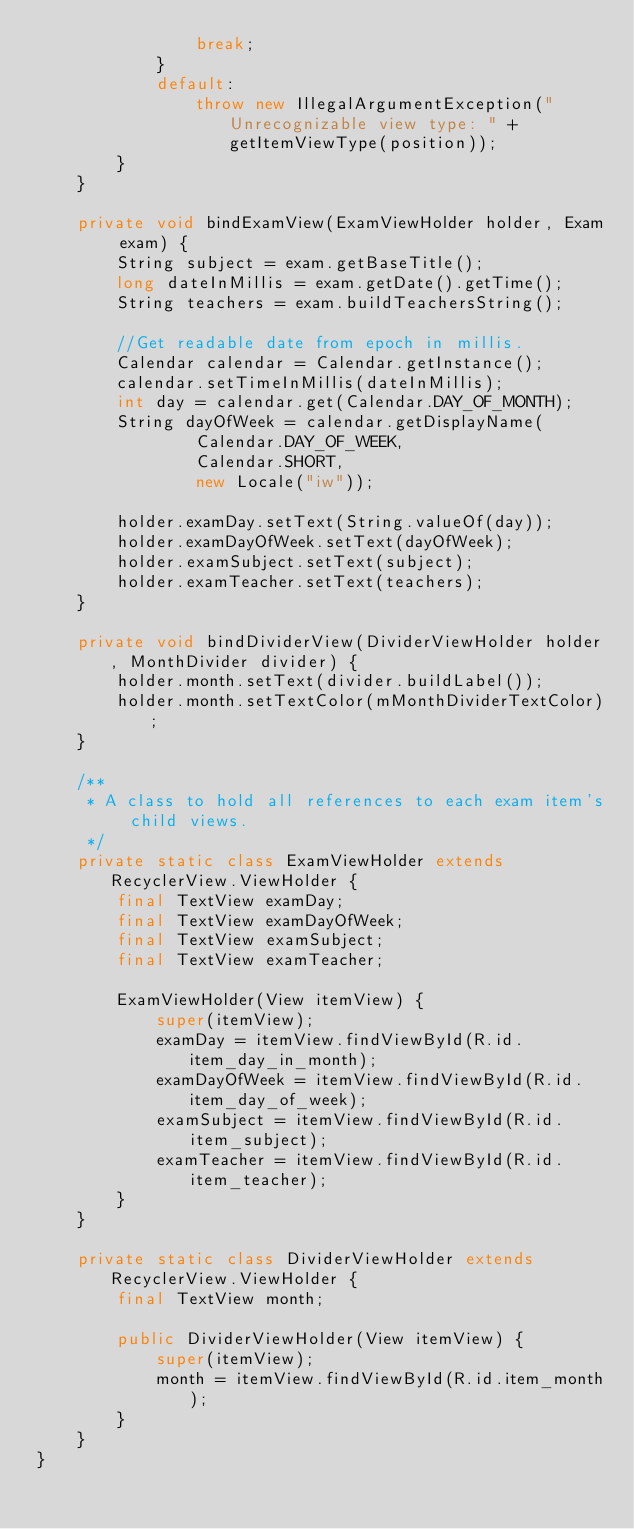<code> <loc_0><loc_0><loc_500><loc_500><_Java_>                break;
            }
            default:
                throw new IllegalArgumentException("Unrecognizable view type: " + getItemViewType(position));
        }
    }

    private void bindExamView(ExamViewHolder holder, Exam exam) {
        String subject = exam.getBaseTitle();
        long dateInMillis = exam.getDate().getTime();
        String teachers = exam.buildTeachersString();

        //Get readable date from epoch in millis.
        Calendar calendar = Calendar.getInstance();
        calendar.setTimeInMillis(dateInMillis);
        int day = calendar.get(Calendar.DAY_OF_MONTH);
        String dayOfWeek = calendar.getDisplayName(
                Calendar.DAY_OF_WEEK,
                Calendar.SHORT,
                new Locale("iw"));

        holder.examDay.setText(String.valueOf(day));
        holder.examDayOfWeek.setText(dayOfWeek);
        holder.examSubject.setText(subject);
        holder.examTeacher.setText(teachers);
    }

    private void bindDividerView(DividerViewHolder holder, MonthDivider divider) {
        holder.month.setText(divider.buildLabel());
        holder.month.setTextColor(mMonthDividerTextColor);
    }

    /**
     * A class to hold all references to each exam item's child views.
     */
    private static class ExamViewHolder extends RecyclerView.ViewHolder {
        final TextView examDay;
        final TextView examDayOfWeek;
        final TextView examSubject;
        final TextView examTeacher;

        ExamViewHolder(View itemView) {
            super(itemView);
            examDay = itemView.findViewById(R.id.item_day_in_month);
            examDayOfWeek = itemView.findViewById(R.id.item_day_of_week);
            examSubject = itemView.findViewById(R.id.item_subject);
            examTeacher = itemView.findViewById(R.id.item_teacher);
        }
    }

    private static class DividerViewHolder extends RecyclerView.ViewHolder {
        final TextView month;

        public DividerViewHolder(View itemView) {
            super(itemView);
            month = itemView.findViewById(R.id.item_month);
        }
    }
}</code> 